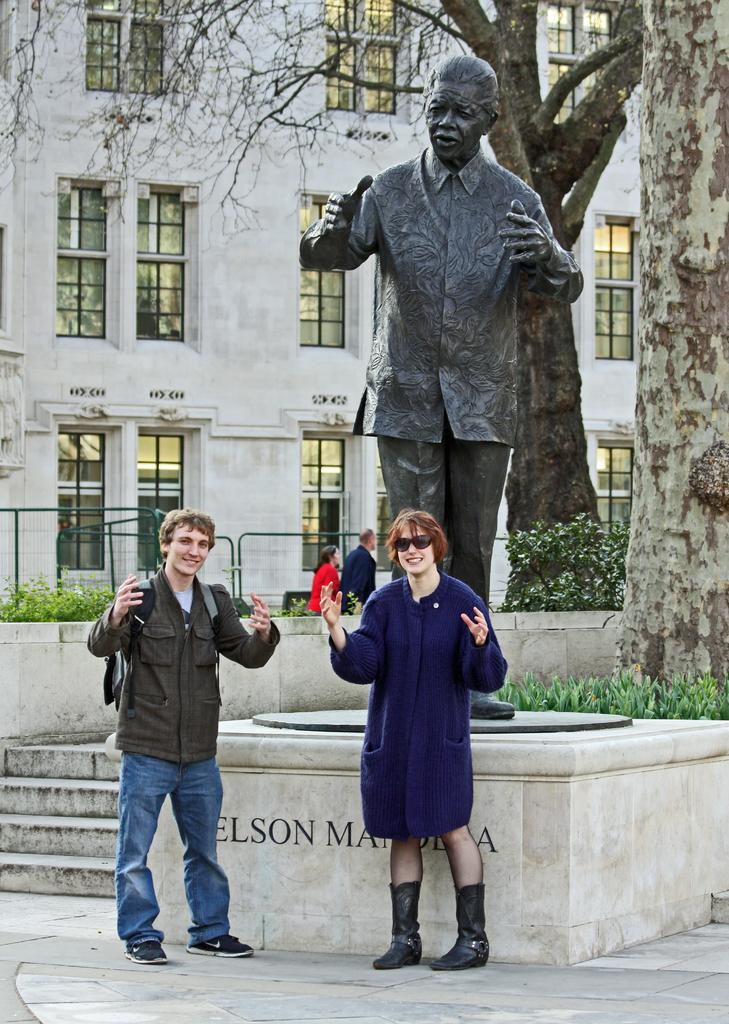Who can be seen in the foreground of the image? There is a couple in the foreground of the image. What are the couple standing in front of? The couple is standing in front of a statue. What can be seen in the background of the image? There are plants, a railing, stairs, trees, and a building in the background of the image. Can you see any hills in the image? There are no hills visible in the image. 